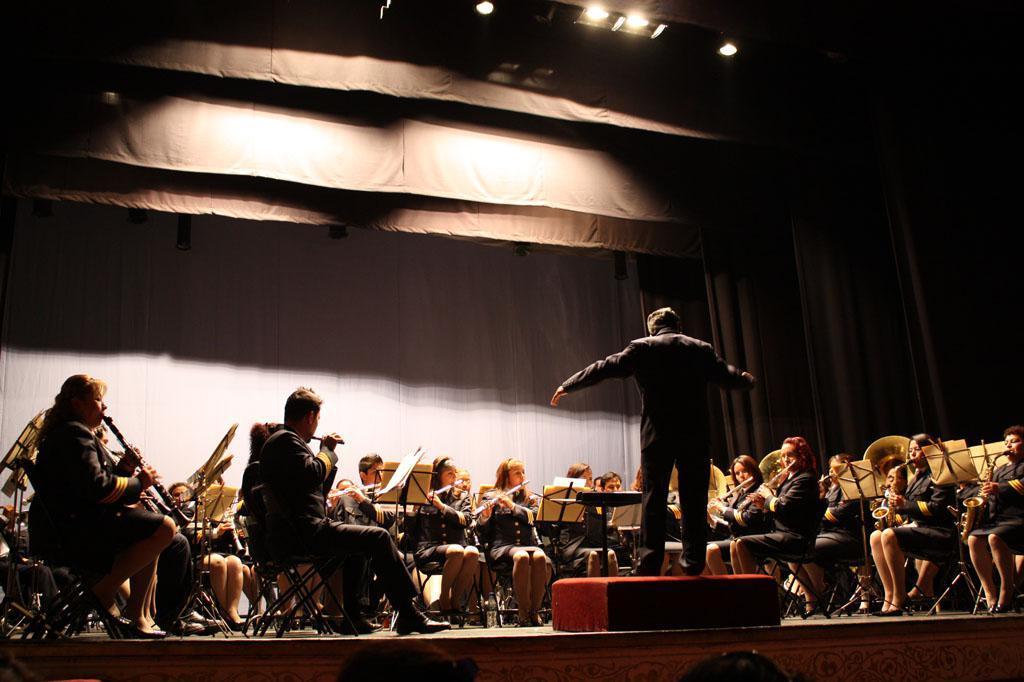Can you describe this image briefly? In the picture we can see a stage on it, we can see many people are sitting on the chairs and playing a musical instrument and in front of them, we can see some stand with some papers on it and we can see one man is standing and giving training to them, he is in black color blazer and in the background we can see a wall with a curtain and to the ceiling we can see some lights. 